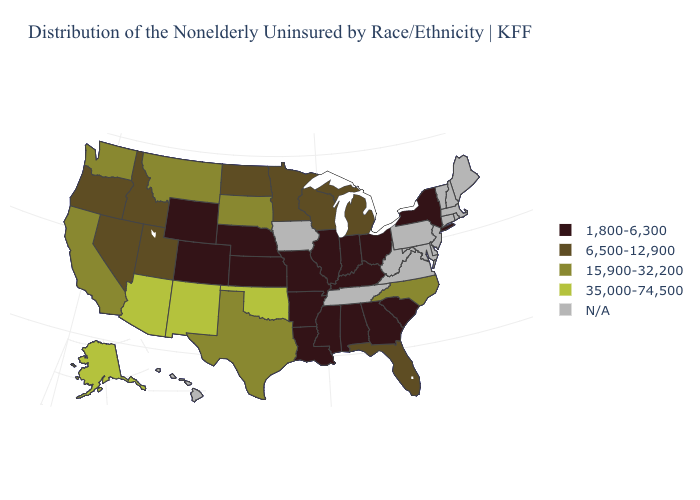Among the states that border Virginia , does Kentucky have the highest value?
Keep it brief. No. Name the states that have a value in the range 15,900-32,200?
Short answer required. California, Montana, North Carolina, South Dakota, Texas, Washington. Name the states that have a value in the range 15,900-32,200?
Short answer required. California, Montana, North Carolina, South Dakota, Texas, Washington. Among the states that border South Dakota , which have the lowest value?
Write a very short answer. Nebraska, Wyoming. What is the value of Louisiana?
Short answer required. 1,800-6,300. What is the value of Arizona?
Short answer required. 35,000-74,500. What is the lowest value in the USA?
Keep it brief. 1,800-6,300. Does the map have missing data?
Be succinct. Yes. Name the states that have a value in the range 35,000-74,500?
Give a very brief answer. Alaska, Arizona, New Mexico, Oklahoma. Name the states that have a value in the range 35,000-74,500?
Write a very short answer. Alaska, Arizona, New Mexico, Oklahoma. What is the value of Delaware?
Give a very brief answer. N/A. Which states have the lowest value in the USA?
Write a very short answer. Alabama, Arkansas, Colorado, Georgia, Illinois, Indiana, Kansas, Kentucky, Louisiana, Mississippi, Missouri, Nebraska, New York, Ohio, South Carolina, Wyoming. Name the states that have a value in the range 1,800-6,300?
Short answer required. Alabama, Arkansas, Colorado, Georgia, Illinois, Indiana, Kansas, Kentucky, Louisiana, Mississippi, Missouri, Nebraska, New York, Ohio, South Carolina, Wyoming. 